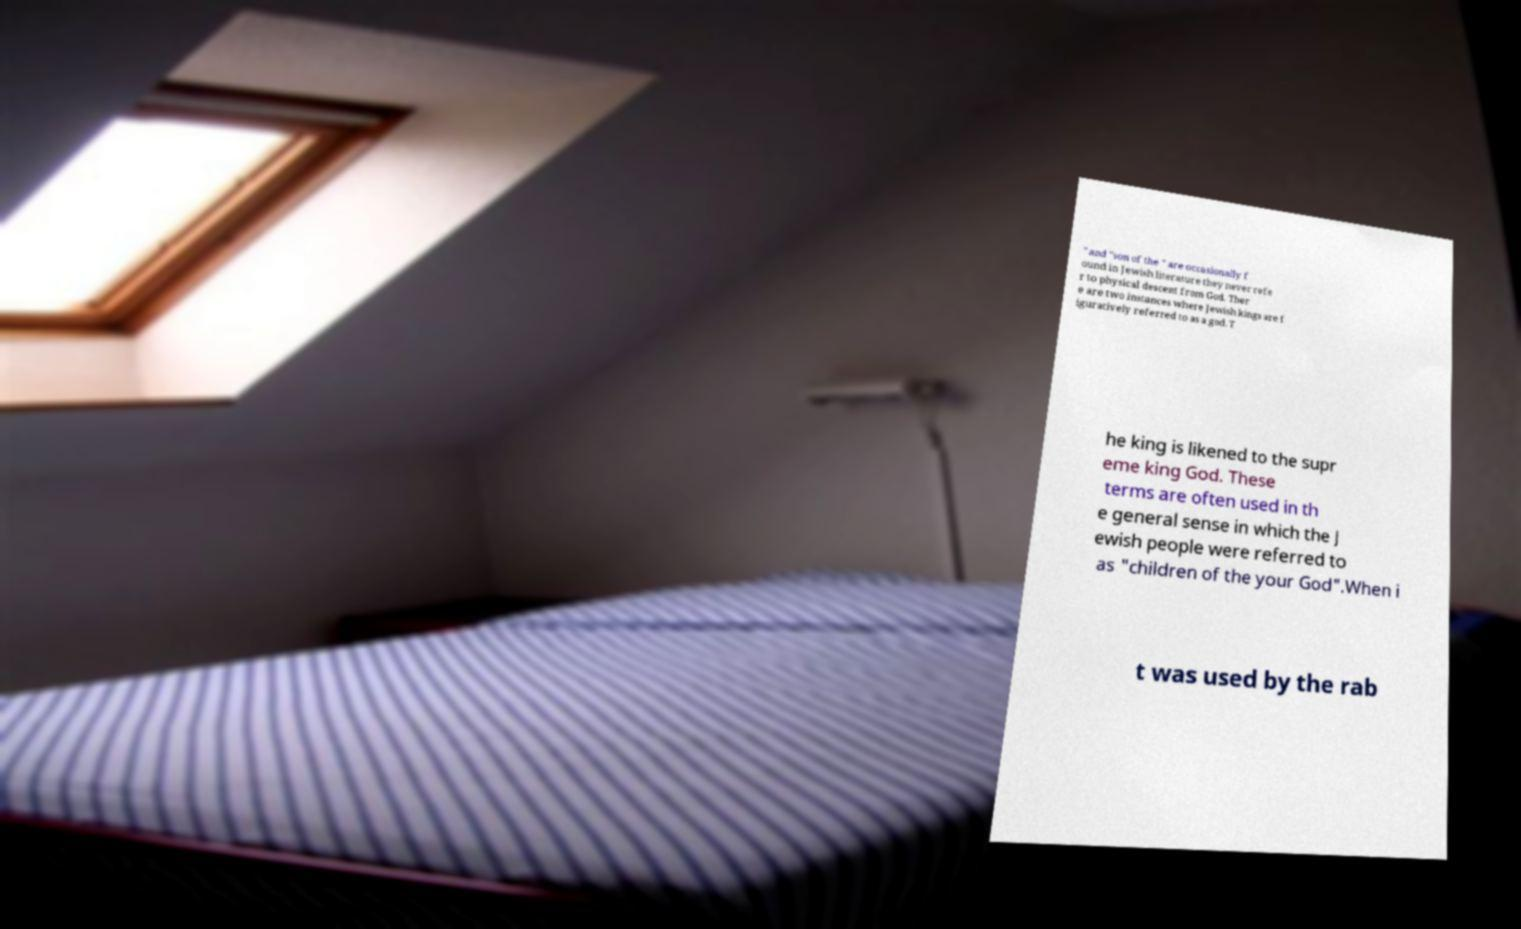Please read and relay the text visible in this image. What does it say? " and "son of the " are occasionally f ound in Jewish literature they never refe r to physical descent from God. Ther e are two instances where Jewish kings are f iguratively referred to as a god. T he king is likened to the supr eme king God. These terms are often used in th e general sense in which the J ewish people were referred to as "children of the your God".When i t was used by the rab 